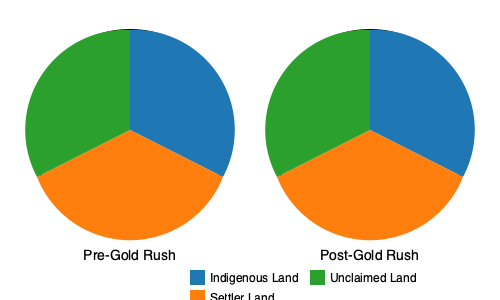Analyze the changes in indigenous land ownership before and after the California Gold Rush using the provided pie charts. Calculate the percentage decrease in indigenous land ownership and explain the implications of this shift on indigenous communities. To analyze the changes in indigenous land ownership and calculate the percentage decrease, we'll follow these steps:

1. Estimate the pre-Gold Rush indigenous land ownership:
   The blue section represents approximately 50% of the circle.

2. Estimate the post-Gold Rush indigenous land ownership:
   The blue section now represents approximately 20% of the circle.

3. Calculate the percentage decrease:
   Percentage decrease = $\frac{\text{Original Value} - \text{New Value}}{\text{Original Value}} \times 100\%$
   $= \frac{50\% - 20\%}{50\%} \times 100\%$
   $= \frac{30\%}{50\%} \times 100\%$
   $= 0.6 \times 100\%$
   $= 60\%$

4. Implications of this shift:
   a) Loss of traditional territories: Indigenous communities lost access to ancestral lands, sacred sites, and natural resources.
   b) Disruption of traditional lifestyles: Reduced land ownership impacted hunting, gathering, and agricultural practices.
   c) Forced relocation: Many indigenous groups were displaced from their original homelands.
   d) Economic hardship: Loss of land led to reduced economic opportunities and increased dependency on the new settler economy.
   e) Cultural erosion: Displacement and reduced access to traditional lands threatened cultural practices and knowledge transmission.
   f) Political marginalization: Loss of land ownership weakened indigenous groups' political influence and sovereignty.
   g) Environmental changes: Settler land use practices often conflicted with indigenous land management, leading to ecological shifts.

The significant decrease in indigenous land ownership (60%) during the Gold Rush era represents a dramatic and rapid transformation of the California landscape, with far-reaching consequences for indigenous communities that continue to impact them to this day.
Answer: 60% decrease; led to loss of traditional territories, cultural erosion, and socio-economic marginalization of indigenous communities. 